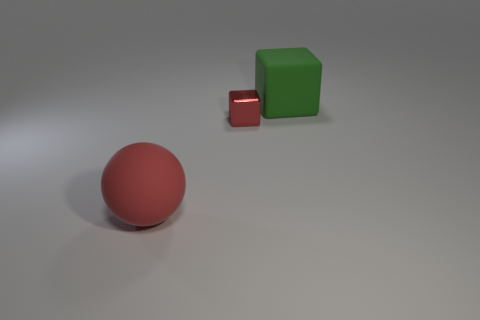Add 3 green rubber blocks. How many objects exist? 6 Subtract all blocks. How many objects are left? 1 Subtract 0 cyan cylinders. How many objects are left? 3 Subtract all red things. Subtract all small red metallic things. How many objects are left? 0 Add 2 red objects. How many red objects are left? 4 Add 2 green spheres. How many green spheres exist? 2 